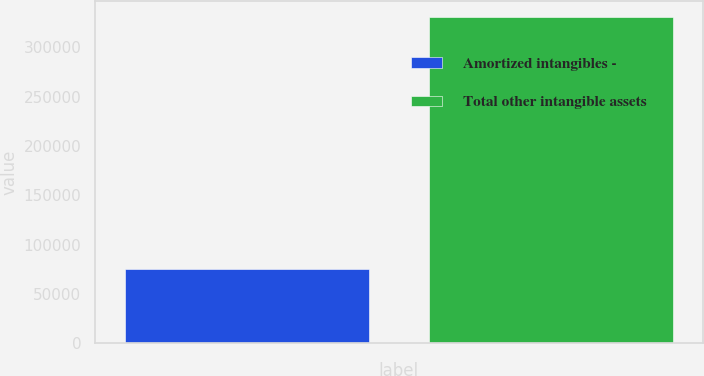Convert chart to OTSL. <chart><loc_0><loc_0><loc_500><loc_500><bar_chart><fcel>Amortized intangibles -<fcel>Total other intangible assets<nl><fcel>75504<fcel>330286<nl></chart> 